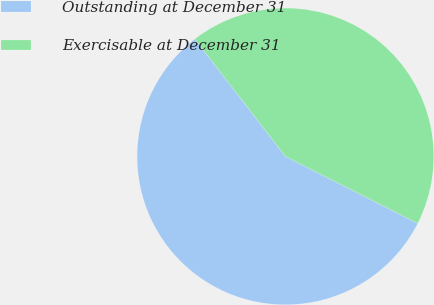Convert chart. <chart><loc_0><loc_0><loc_500><loc_500><pie_chart><fcel>Outstanding at December 31<fcel>Exercisable at December 31<nl><fcel>57.08%<fcel>42.92%<nl></chart> 